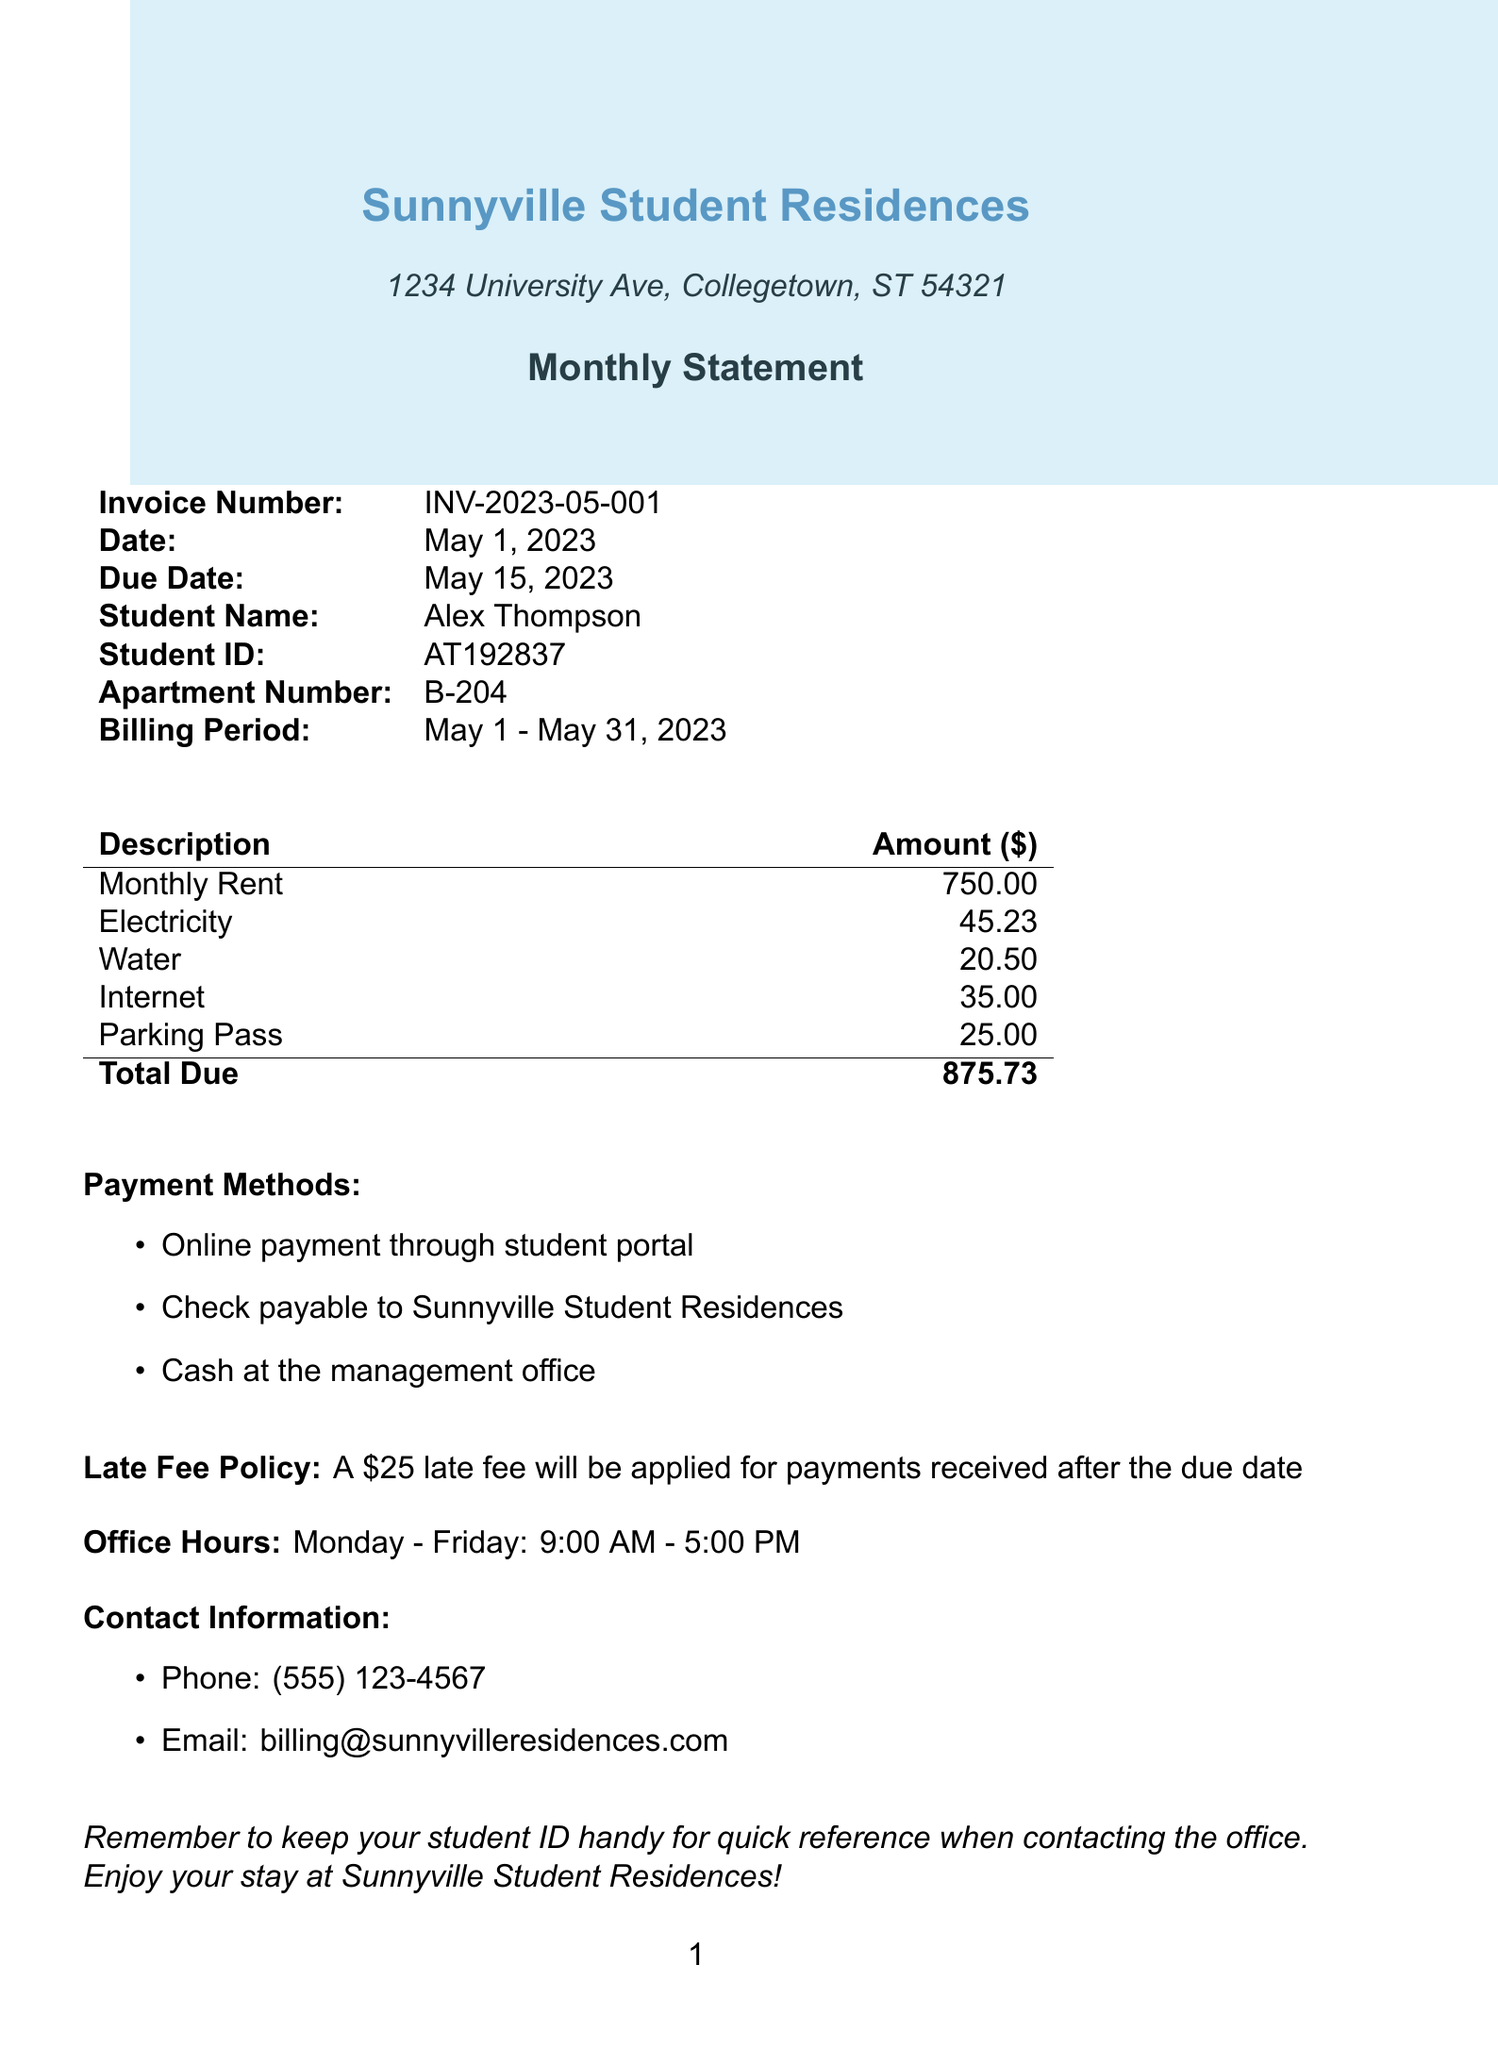what is the invoice number? The invoice number is stated clearly at the top of the document for reference.
Answer: INV-2023-05-001 what is the total amount due? The total amount due is provided at the bottom of the charges table in the document.
Answer: 875.73 who is the student named in the invoice? The document specifies the name of the student for whom the invoice is issued.
Answer: Alex Thompson when is the payment due date? The due date for the payment is highlighted in the invoice to ensure timely payments.
Answer: May 15, 2023 what are the available payment methods? The document lists multiple ways for the student to make payments for their charges.
Answer: Online payment through student portal, Check payable to Sunnyville Student Residences, Cash at the management office how much is the late fee? The late fee policy details the amount that will be charged if payment is made after the due date.
Answer: 25 what is included in the billing period? The billing period indicates the timeframe during which the charges apply, as shown in the invoice.
Answer: May 1 - May 31, 2023 what is the apartment number? The apartment number is specified for identification in the context of the student residence.
Answer: B-204 what is the contact email for billing inquiries? The document provides an email address for the student to reach out with questions about billing.
Answer: billing@sunnyvilleresidences.com 